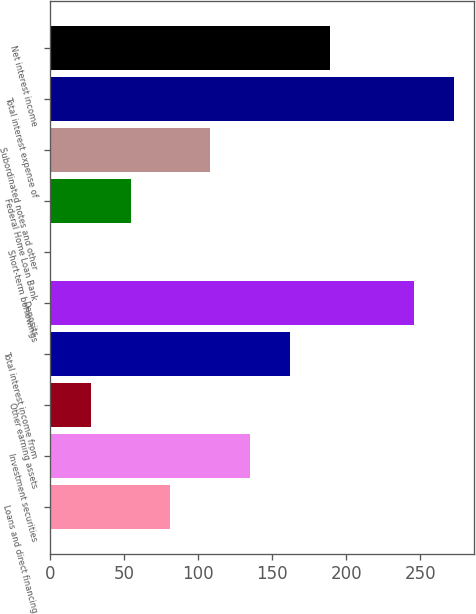Convert chart to OTSL. <chart><loc_0><loc_0><loc_500><loc_500><bar_chart><fcel>Loans and direct financing<fcel>Investment securities<fcel>Other earning assets<fcel>Total interest income from<fcel>Deposits<fcel>Short-term borrowings<fcel>Federal Home Loan Bank<fcel>Subordinated notes and other<fcel>Total interest expense of<fcel>Net interest income<nl><fcel>81.26<fcel>135.1<fcel>27.42<fcel>162.02<fcel>246<fcel>0.5<fcel>54.34<fcel>108.18<fcel>272.92<fcel>188.94<nl></chart> 